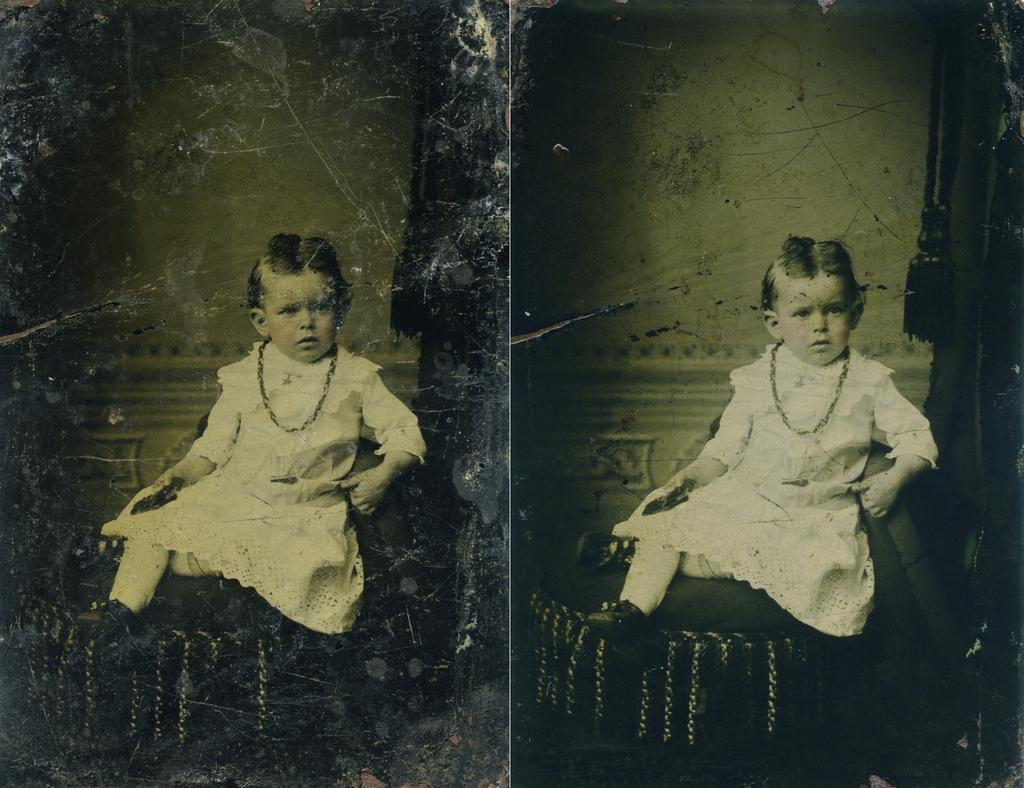How many images are there in the picture? There are two similar images in the picture. What is the child doing in each image? In each image, a child is sitting. What is the child wearing in the images? The child is wearing a white dress and a chain. What type of ring can be seen on the child's finger in the image? There is no ring visible on the child's finger in the image. What kind of soda is the child holding in the image? There is no soda present in the image. 